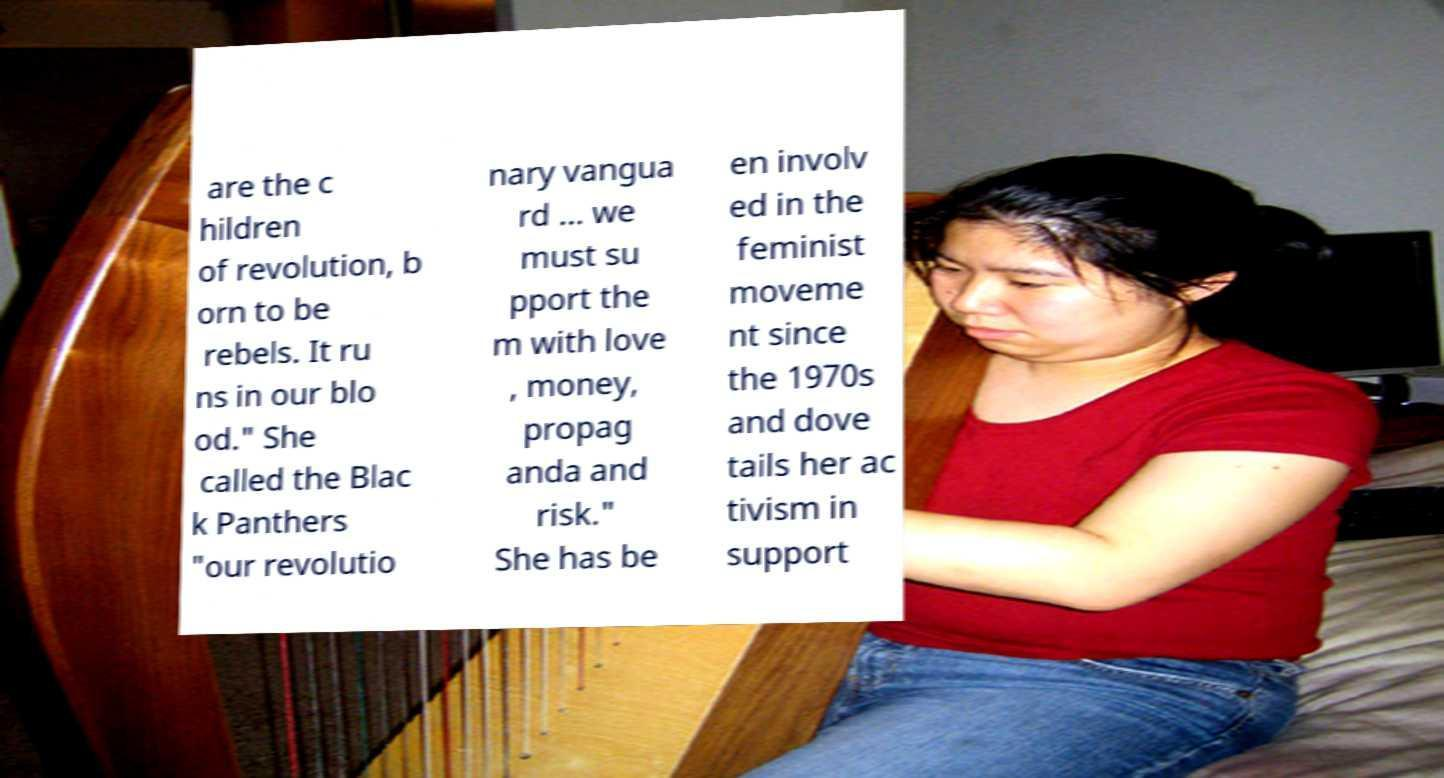I need the written content from this picture converted into text. Can you do that? are the c hildren of revolution, b orn to be rebels. It ru ns in our blo od." She called the Blac k Panthers "our revolutio nary vangua rd ... we must su pport the m with love , money, propag anda and risk." She has be en involv ed in the feminist moveme nt since the 1970s and dove tails her ac tivism in support 